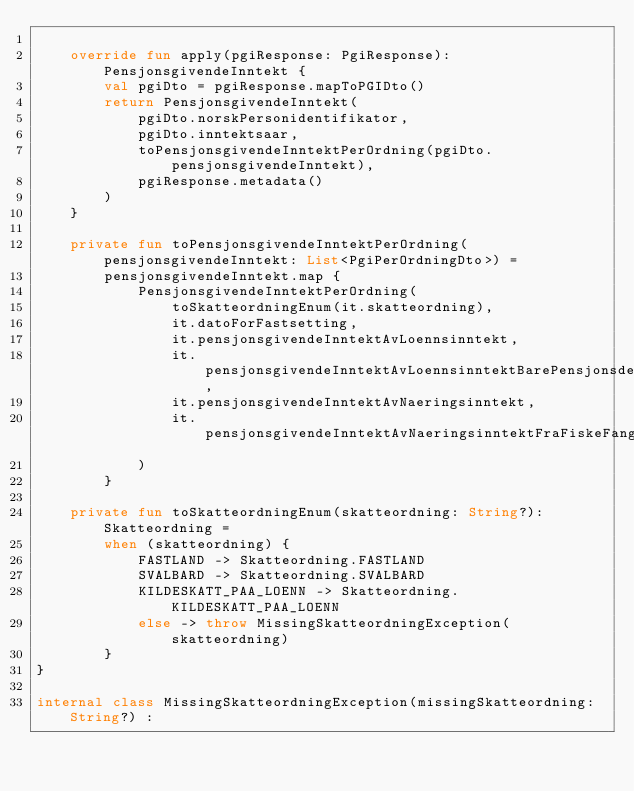Convert code to text. <code><loc_0><loc_0><loc_500><loc_500><_Kotlin_>
    override fun apply(pgiResponse: PgiResponse): PensjonsgivendeInntekt {
        val pgiDto = pgiResponse.mapToPGIDto()
        return PensjonsgivendeInntekt(
            pgiDto.norskPersonidentifikator,
            pgiDto.inntektsaar,
            toPensjonsgivendeInntektPerOrdning(pgiDto.pensjonsgivendeInntekt),
            pgiResponse.metadata()
        )
    }

    private fun toPensjonsgivendeInntektPerOrdning(pensjonsgivendeInntekt: List<PgiPerOrdningDto>) =
        pensjonsgivendeInntekt.map {
            PensjonsgivendeInntektPerOrdning(
                toSkatteordningEnum(it.skatteordning),
                it.datoForFastsetting,
                it.pensjonsgivendeInntektAvLoennsinntekt,
                it.pensjonsgivendeInntektAvLoennsinntektBarePensjonsdel,
                it.pensjonsgivendeInntektAvNaeringsinntekt,
                it.pensjonsgivendeInntektAvNaeringsinntektFraFiskeFangstEllerFamiliebarnehage
            )
        }

    private fun toSkatteordningEnum(skatteordning: String?): Skatteordning =
        when (skatteordning) {
            FASTLAND -> Skatteordning.FASTLAND
            SVALBARD -> Skatteordning.SVALBARD
            KILDESKATT_PAA_LOENN -> Skatteordning.KILDESKATT_PAA_LOENN
            else -> throw MissingSkatteordningException(skatteordning)
        }
}

internal class MissingSkatteordningException(missingSkatteordning: String?) :</code> 